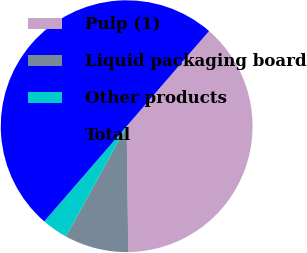<chart> <loc_0><loc_0><loc_500><loc_500><pie_chart><fcel>Pulp (1)<fcel>Liquid packaging board<fcel>Other products<fcel>Total<nl><fcel>38.44%<fcel>8.22%<fcel>3.34%<fcel>50.0%<nl></chart> 